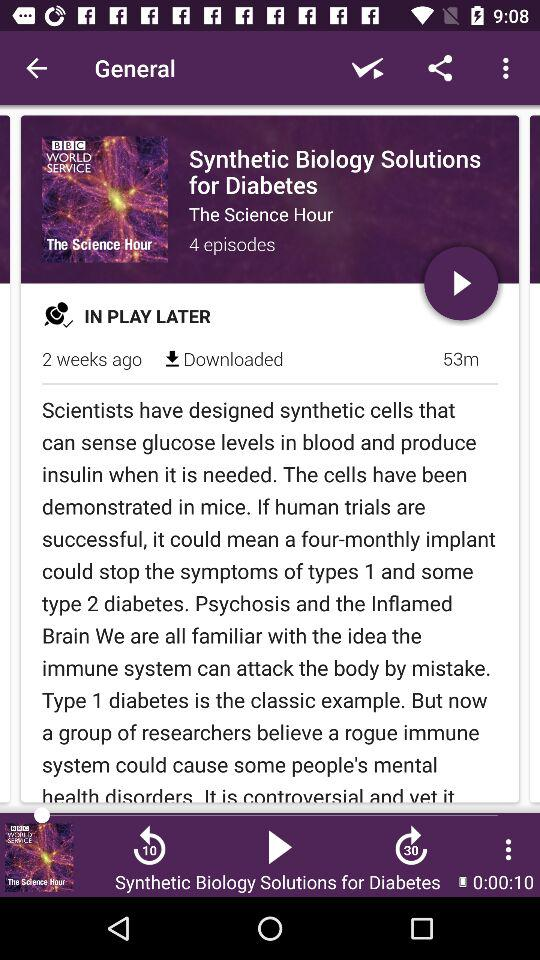How many episodes does The Science Hour have?
Answer the question using a single word or phrase. 4 